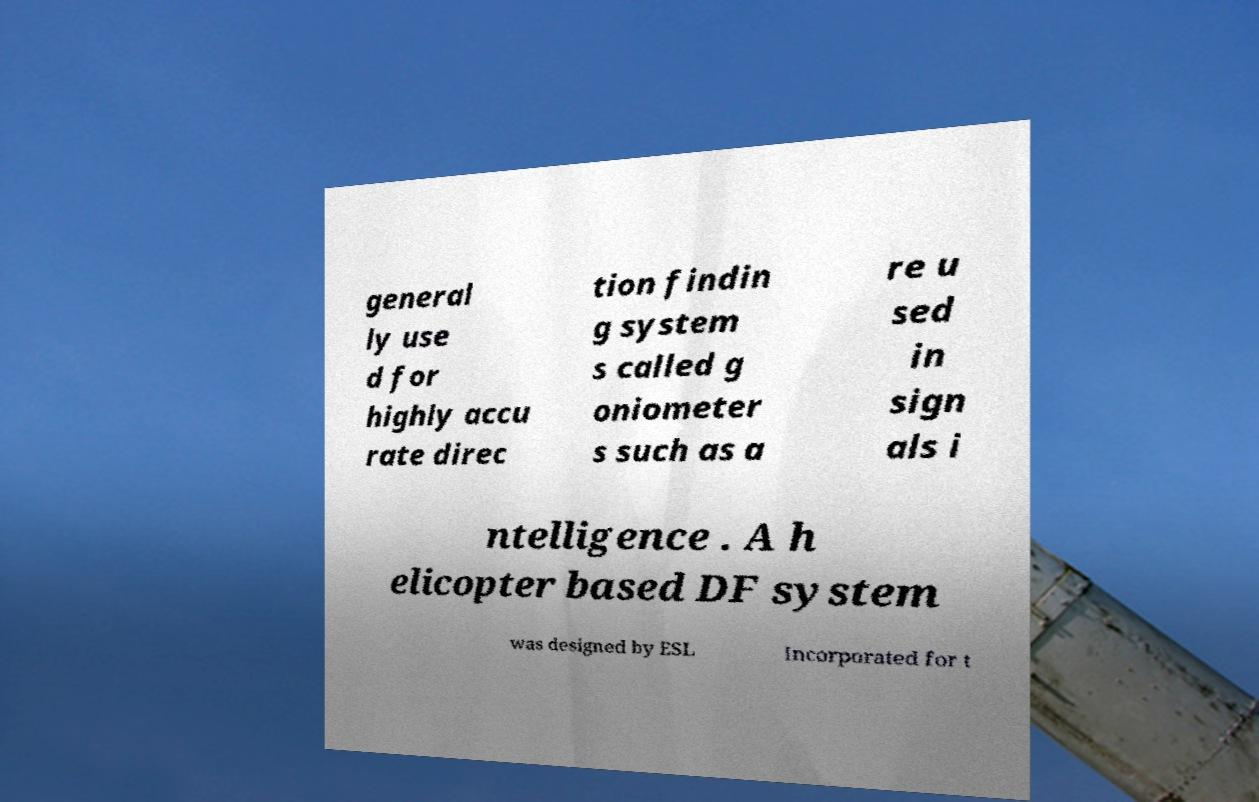Can you read and provide the text displayed in the image?This photo seems to have some interesting text. Can you extract and type it out for me? general ly use d for highly accu rate direc tion findin g system s called g oniometer s such as a re u sed in sign als i ntelligence . A h elicopter based DF system was designed by ESL Incorporated for t 